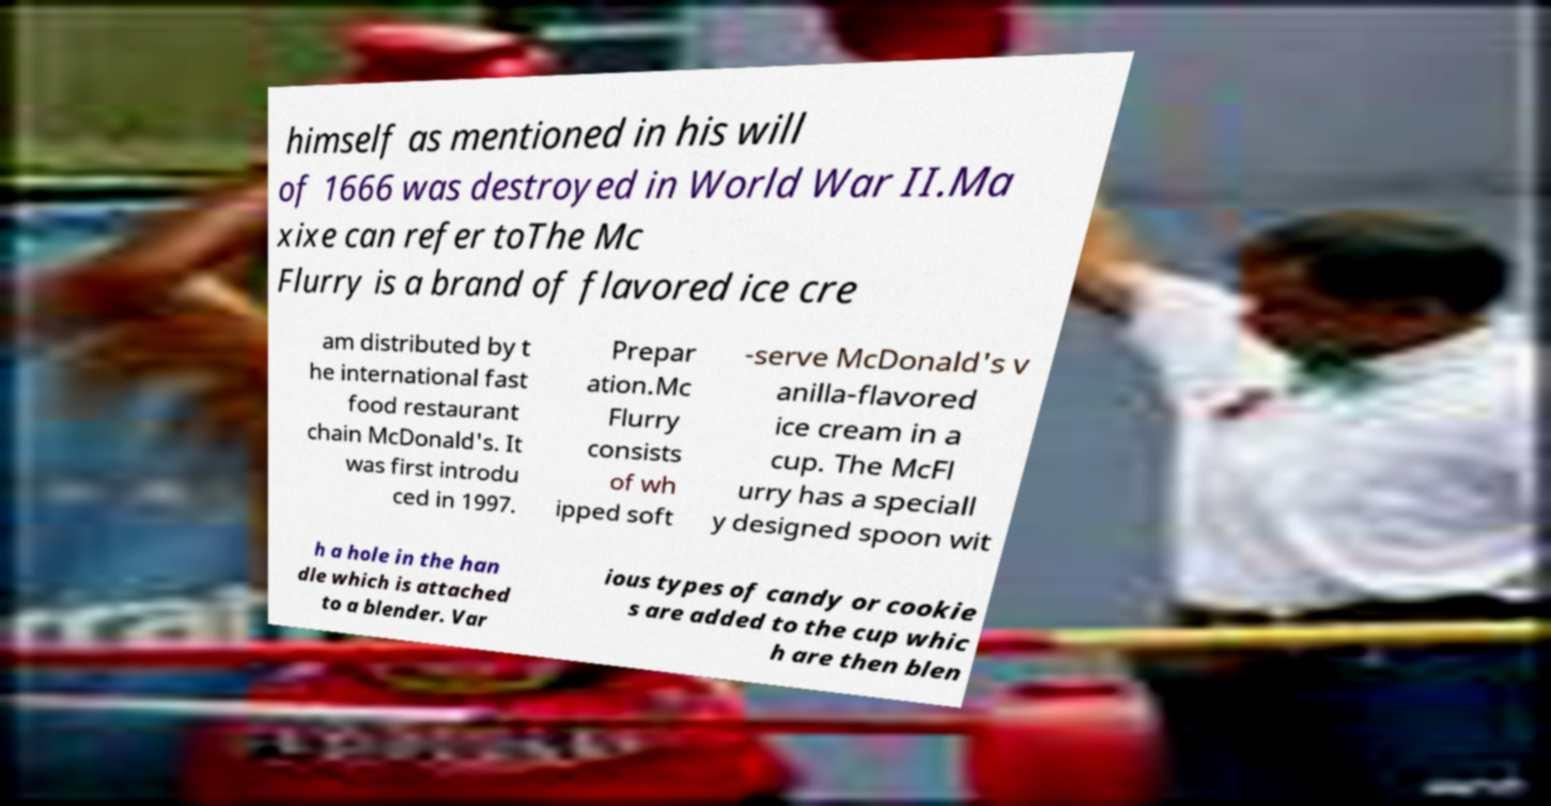Could you assist in decoding the text presented in this image and type it out clearly? himself as mentioned in his will of 1666 was destroyed in World War II.Ma xixe can refer toThe Mc Flurry is a brand of flavored ice cre am distributed by t he international fast food restaurant chain McDonald's. It was first introdu ced in 1997. Prepar ation.Mc Flurry consists of wh ipped soft -serve McDonald's v anilla-flavored ice cream in a cup. The McFl urry has a speciall y designed spoon wit h a hole in the han dle which is attached to a blender. Var ious types of candy or cookie s are added to the cup whic h are then blen 